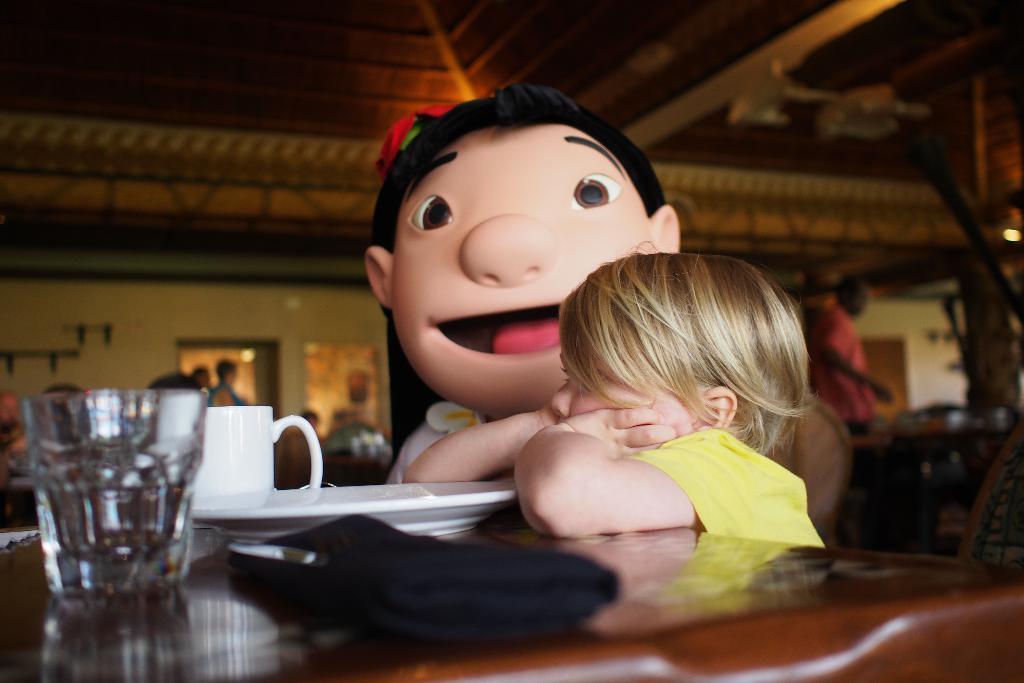Describe this image in one or two sentences. In this image I can see a child wearing yellow colored dress and a toy and I can see a brown colored table. On the table I can see a plate, a cup, a glass and a black colored object. In the background I can see few persons, the wall, the ceiling and a light. 